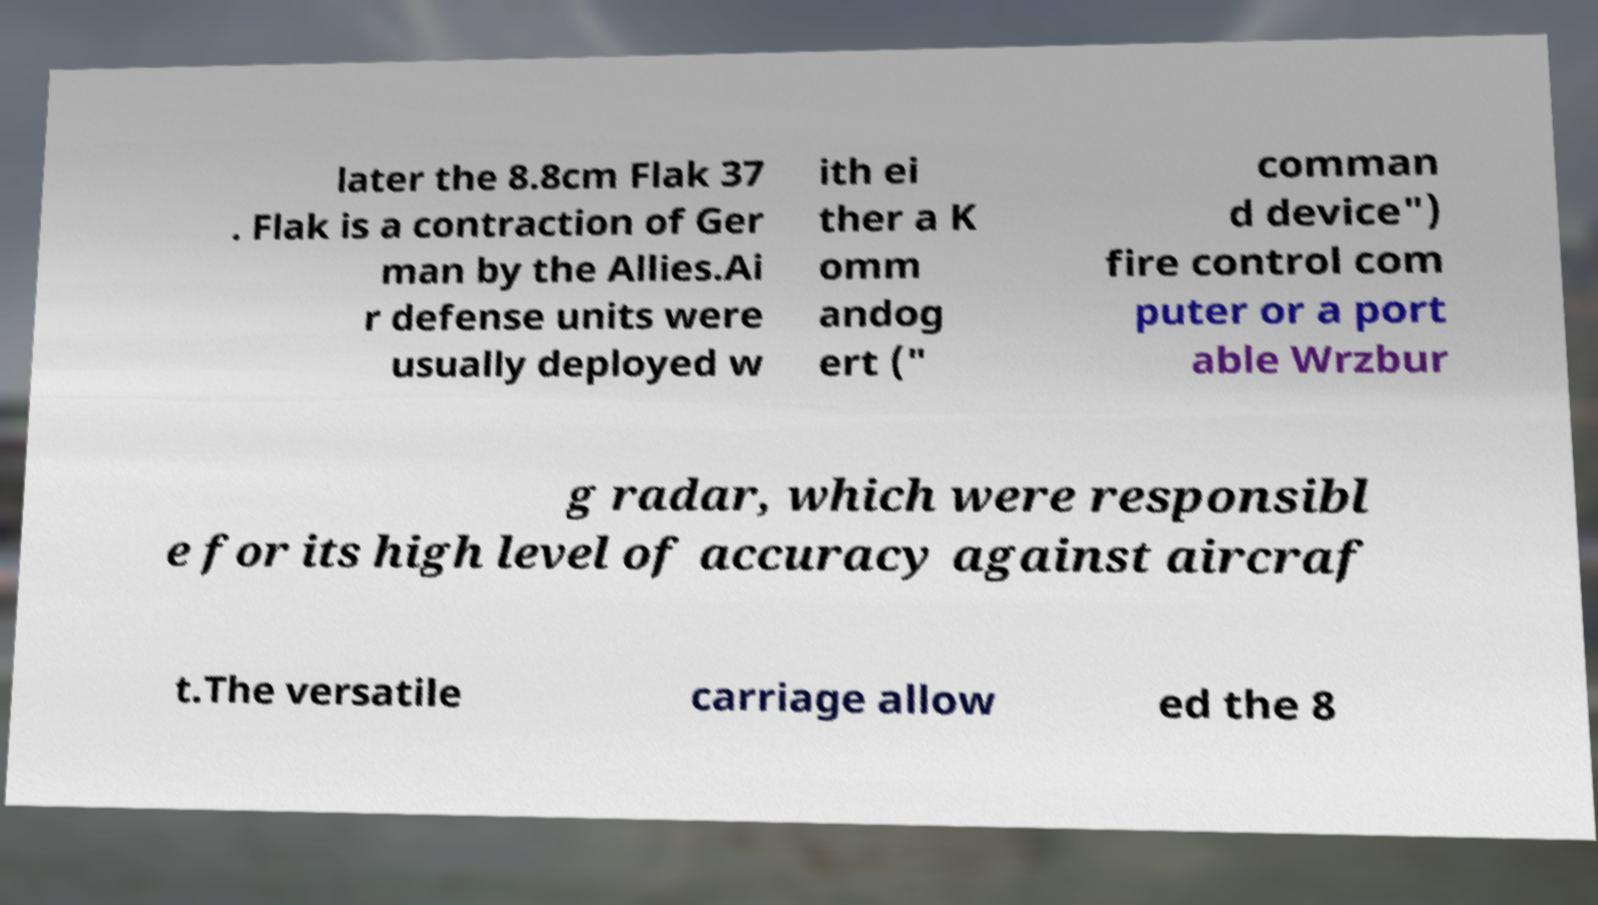What messages or text are displayed in this image? I need them in a readable, typed format. later the 8.8cm Flak 37 . Flak is a contraction of Ger man by the Allies.Ai r defense units were usually deployed w ith ei ther a K omm andog ert (" comman d device") fire control com puter or a port able Wrzbur g radar, which were responsibl e for its high level of accuracy against aircraf t.The versatile carriage allow ed the 8 